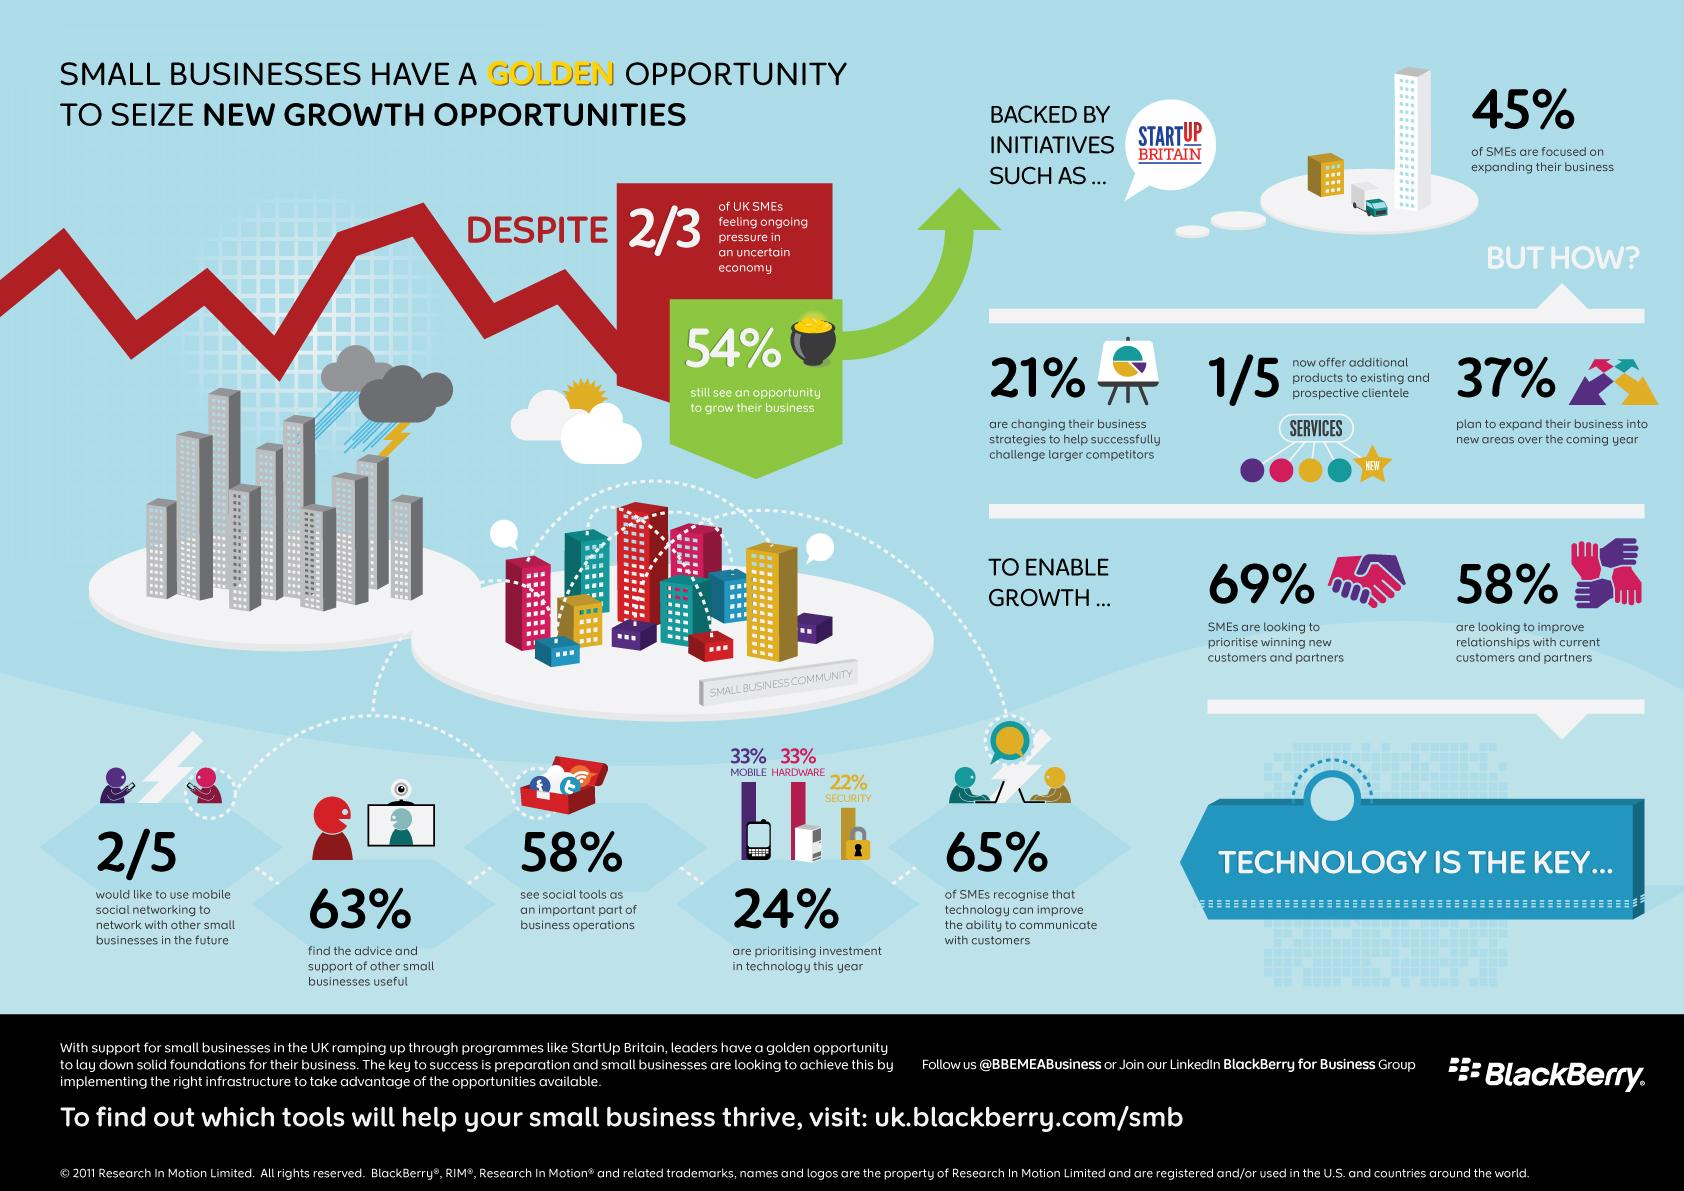Specify some key components in this picture. A significant proportion of SMEs in the UK, approximately 35%, do not recognize that technology can enhance their ability to communicate with customers. According to the data, a majority of UK SMEs, or 55%, are not prioritizing business expansion. A large majority of UK SMEs, 58%, are looking to strengthen their relationships with current customers and partners. According to a recent survey, 33% of SMEs in the UK are prioritizing investment in hardware technologies this year. According to a survey, 63% of UK SMEs find the support of other small businesses to be useful. 